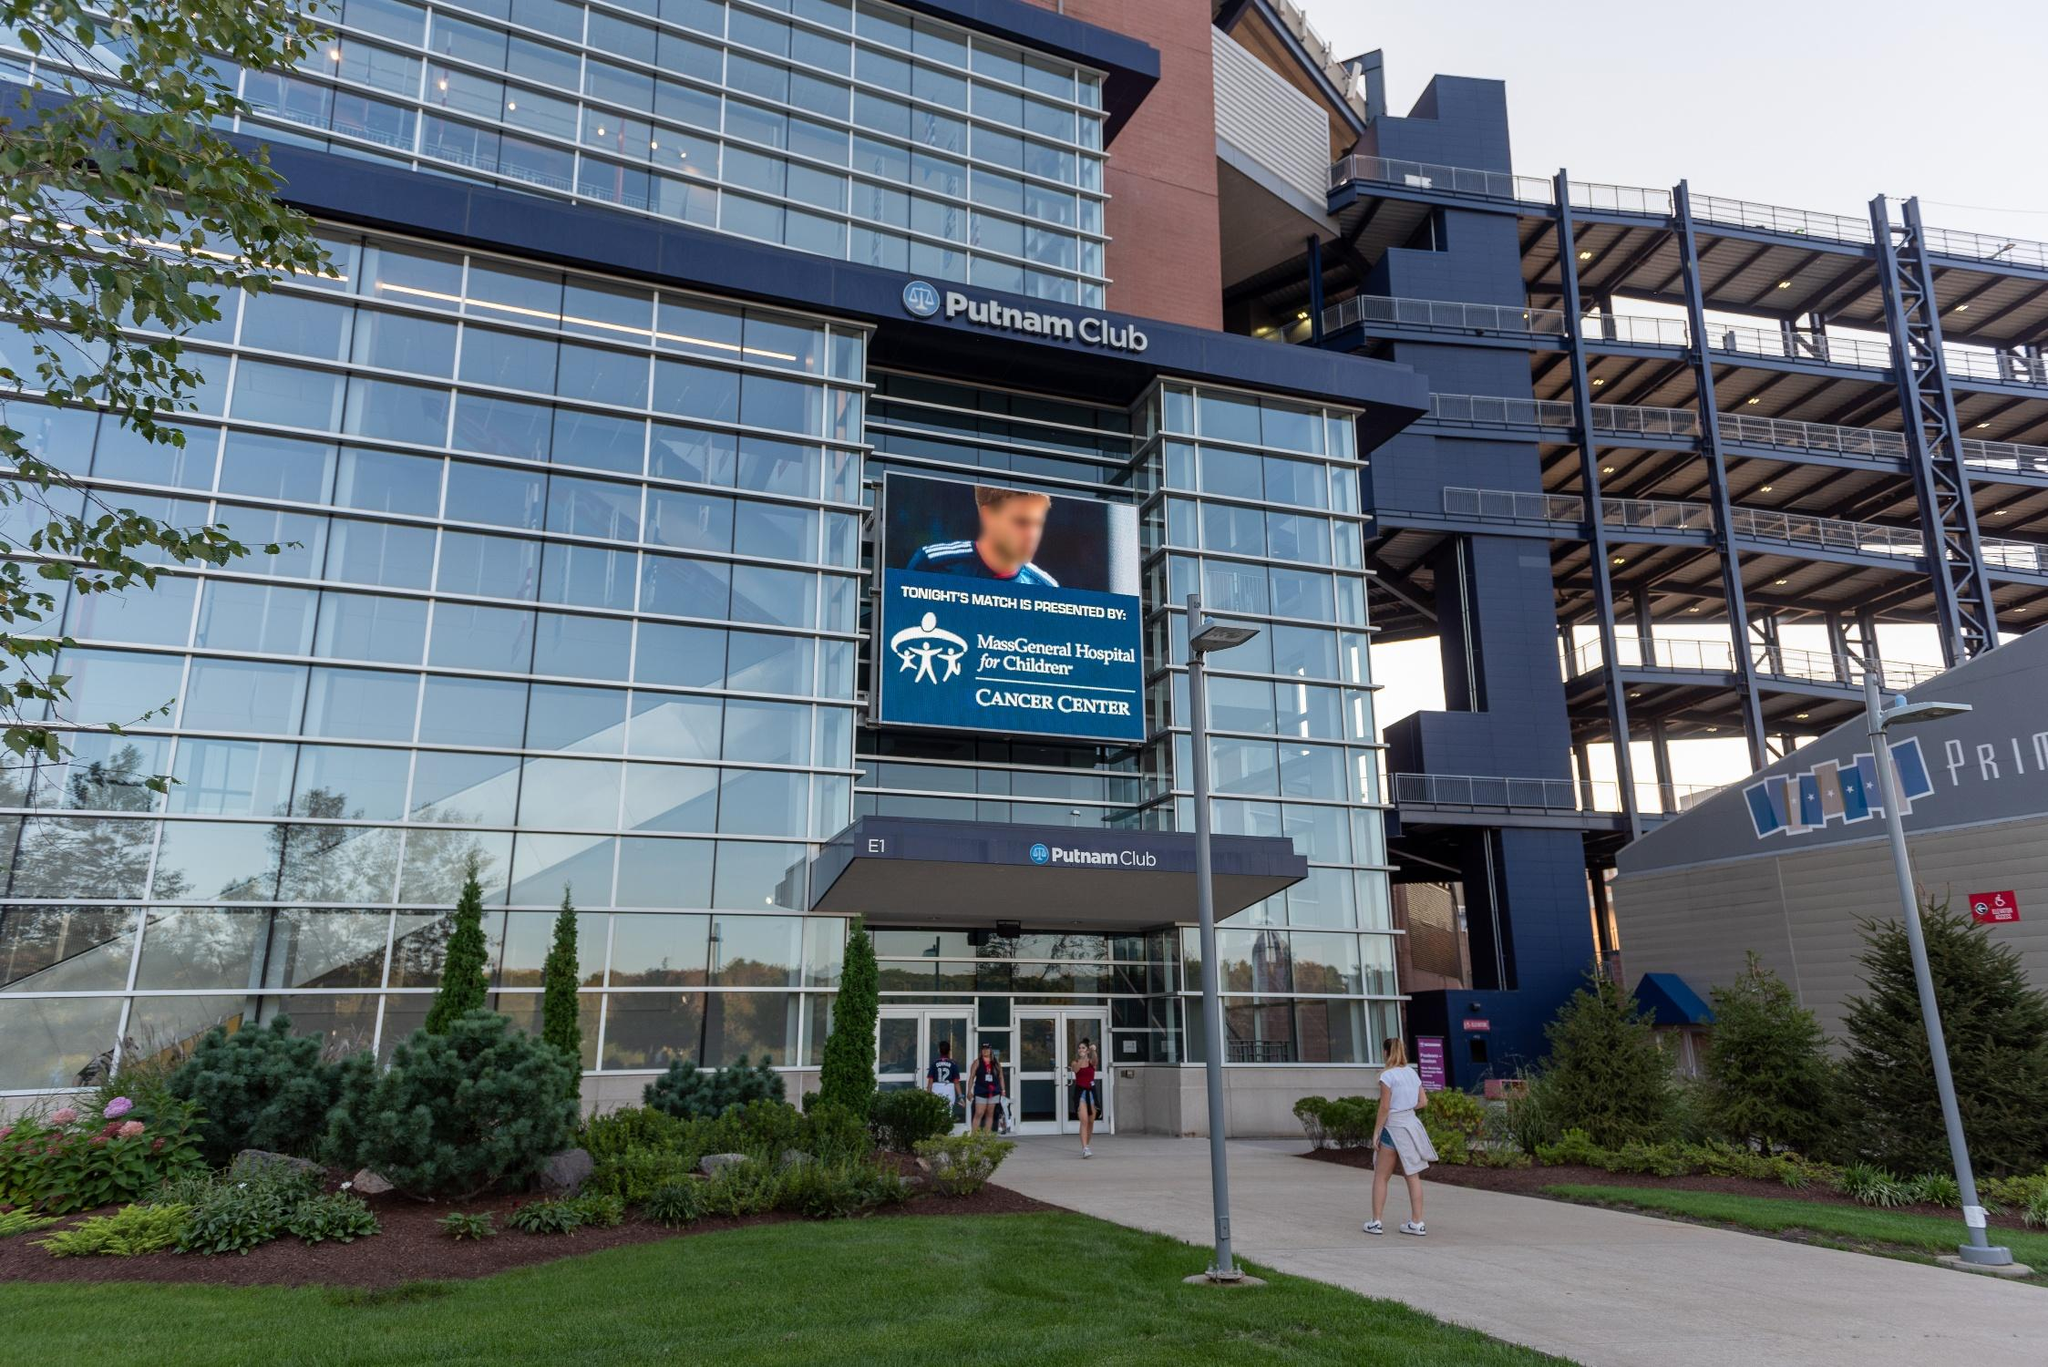Envision the future advancements and potential changes to this venue. In the next decade, the Putnam Club could evolve into a technologically advanced hub for sports and entertainment. Embracing smart technology, the venue might adopt AI-driven systems for crowd management, security, and personalized visitor experiences. Enhanced digital interfaces could offer augmented reality (AR) experiences, allowing visitors to engage with interactive displays about the history of events hosted at the venue. Sustainable practices might also be prioritized, with green roofing, solar panels, and advanced waste management systems becoming integral parts of the infrastructure. Additionally, collaborations with more health and wellness organizations could enhance community engagement, making the venue a center for educational and health-related events beyond just entertainment. 